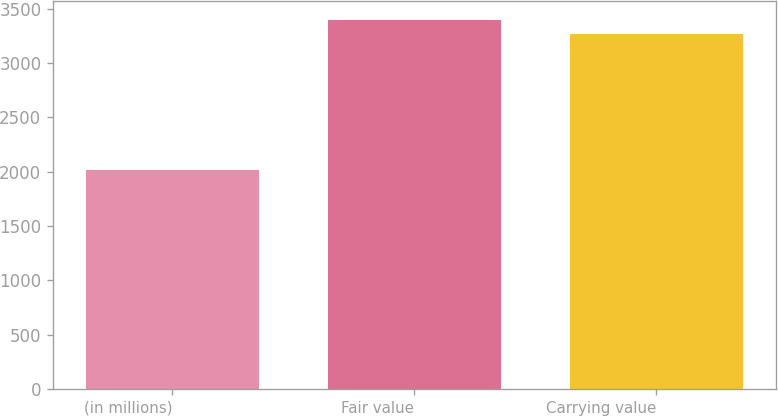Convert chart to OTSL. <chart><loc_0><loc_0><loc_500><loc_500><bar_chart><fcel>(in millions)<fcel>Fair value<fcel>Carrying value<nl><fcel>2016<fcel>3399.68<fcel>3267.8<nl></chart> 